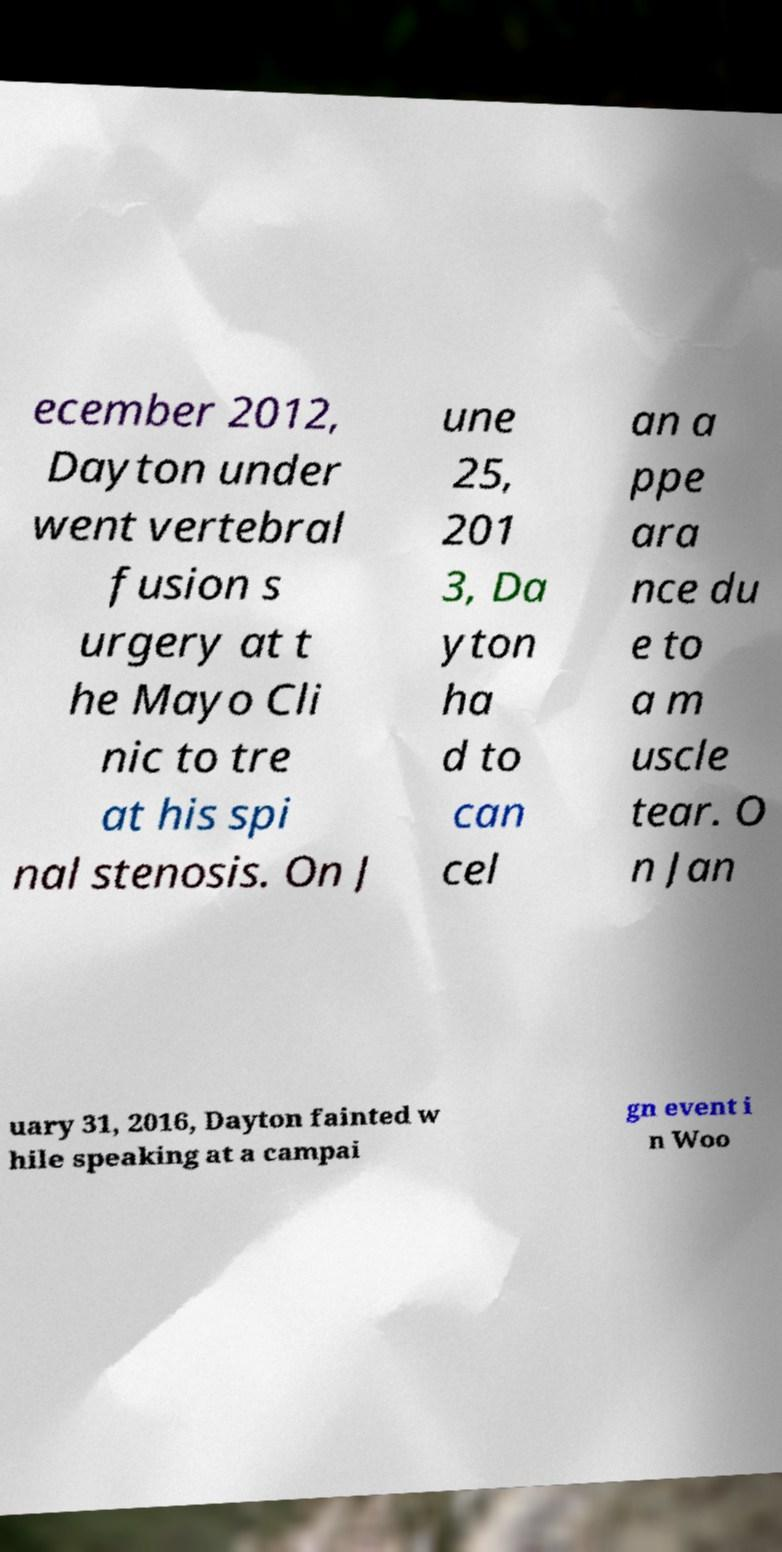Can you accurately transcribe the text from the provided image for me? ecember 2012, Dayton under went vertebral fusion s urgery at t he Mayo Cli nic to tre at his spi nal stenosis. On J une 25, 201 3, Da yton ha d to can cel an a ppe ara nce du e to a m uscle tear. O n Jan uary 31, 2016, Dayton fainted w hile speaking at a campai gn event i n Woo 